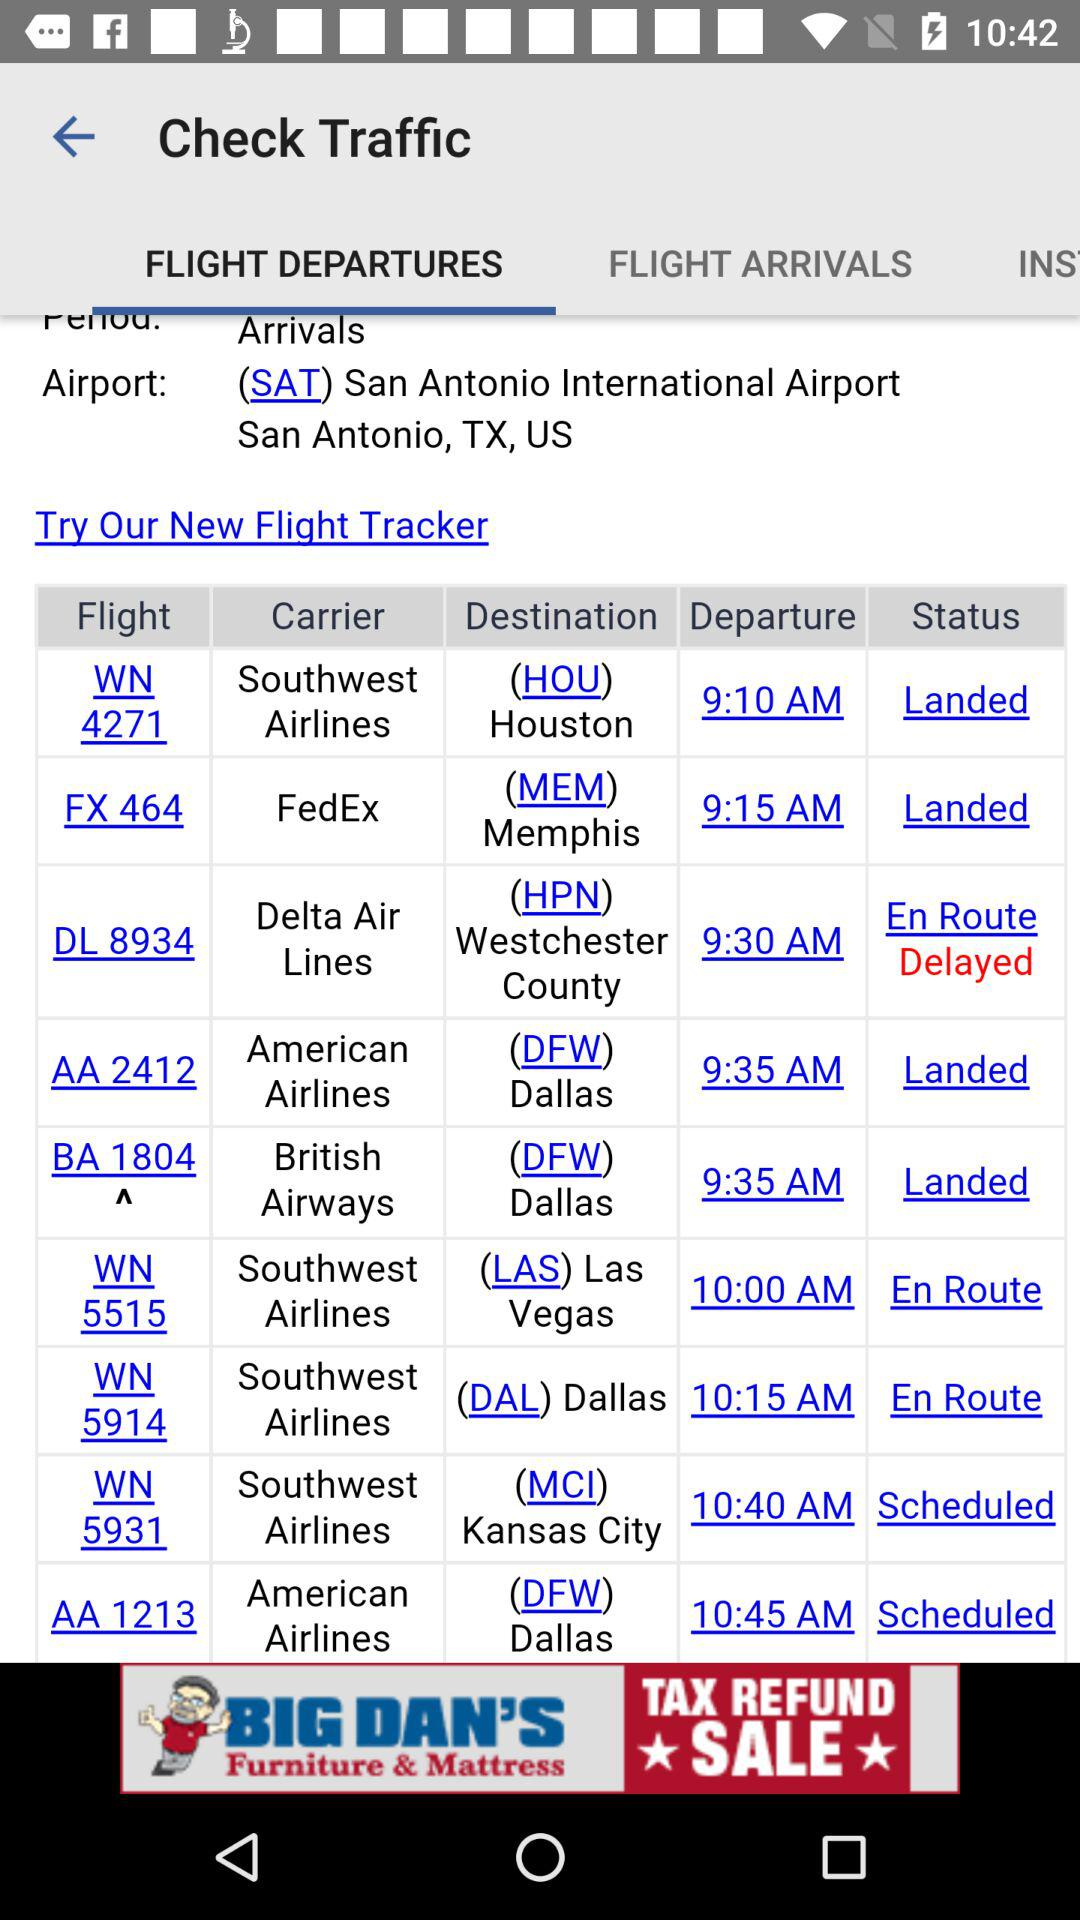What is the status of "Las Vegas" flight? The status of "Las Vegas" flight is "En Route". 